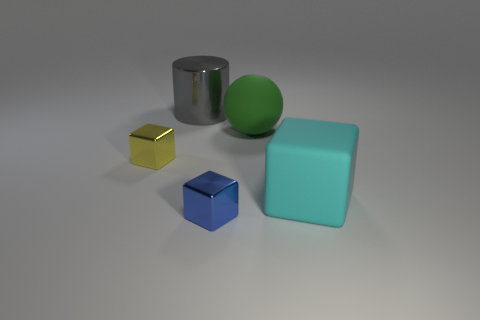Does the cyan rubber thing have the same shape as the big rubber object behind the tiny yellow cube?
Provide a short and direct response. No. What number of things are tiny things left of the green matte thing or blocks in front of the large rubber block?
Make the answer very short. 2. There is a small thing that is on the right side of the gray metallic cylinder; what shape is it?
Provide a short and direct response. Cube. There is a small metallic object in front of the cyan cube; is its shape the same as the yellow thing?
Your answer should be very brief. Yes. What number of things are tiny objects behind the tiny blue metal block or big green cylinders?
Keep it short and to the point. 1. What color is the other metallic thing that is the same shape as the small yellow thing?
Give a very brief answer. Blue. Is there anything else that has the same color as the large sphere?
Provide a short and direct response. No. What size is the blue shiny block on the right side of the big cylinder?
Your answer should be compact. Small. There is a big cylinder; is it the same color as the big thing that is in front of the yellow metal object?
Make the answer very short. No. How many other objects are the same material as the large cyan thing?
Give a very brief answer. 1. 